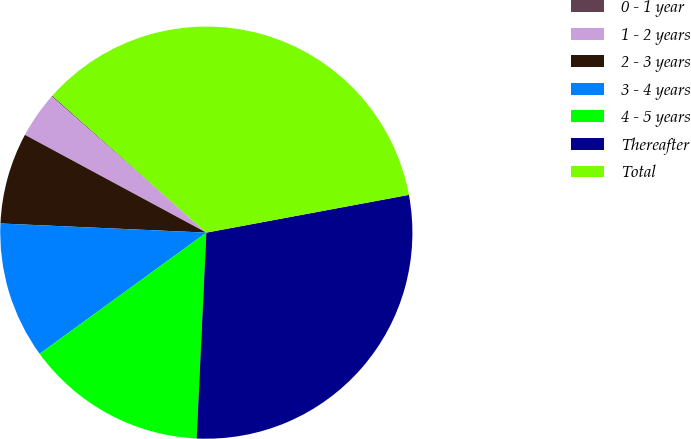Convert chart to OTSL. <chart><loc_0><loc_0><loc_500><loc_500><pie_chart><fcel>0 - 1 year<fcel>1 - 2 years<fcel>2 - 3 years<fcel>3 - 4 years<fcel>4 - 5 years<fcel>Thereafter<fcel>Total<nl><fcel>0.08%<fcel>3.62%<fcel>7.16%<fcel>10.71%<fcel>14.25%<fcel>28.68%<fcel>35.5%<nl></chart> 